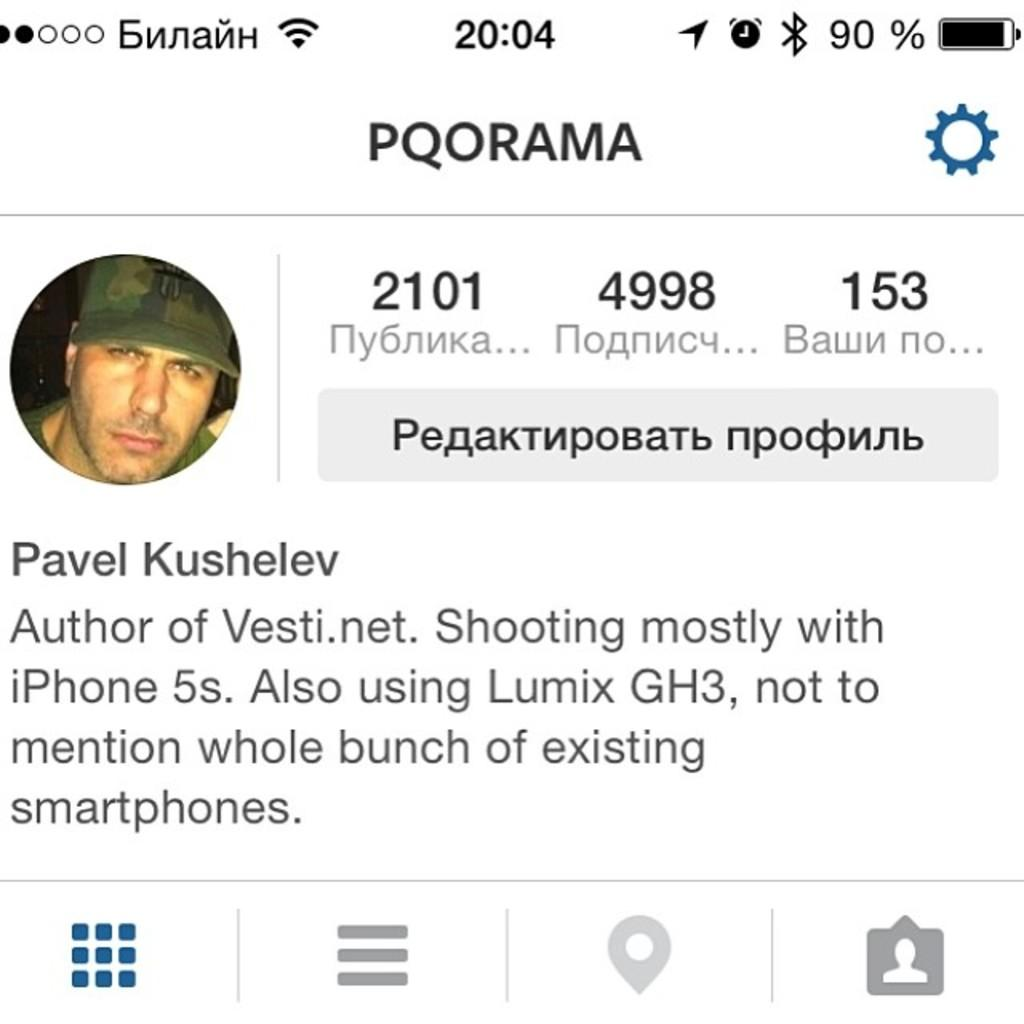What is the main subject of the image? The main subject of the image is a web page. What can be seen on the web page? There is a man on the web page, and he is wearing a cap. What other elements are present on the web page? There are symbols and text on the web page. What type of unit can be seen in the image? There is no unit present in the image; it is a web page with a man wearing a cap, symbols, and text. What is the creator of the web page wearing in the image? The creator of the web page is not visible in the image; only the man on the web page is wearing a cap. 